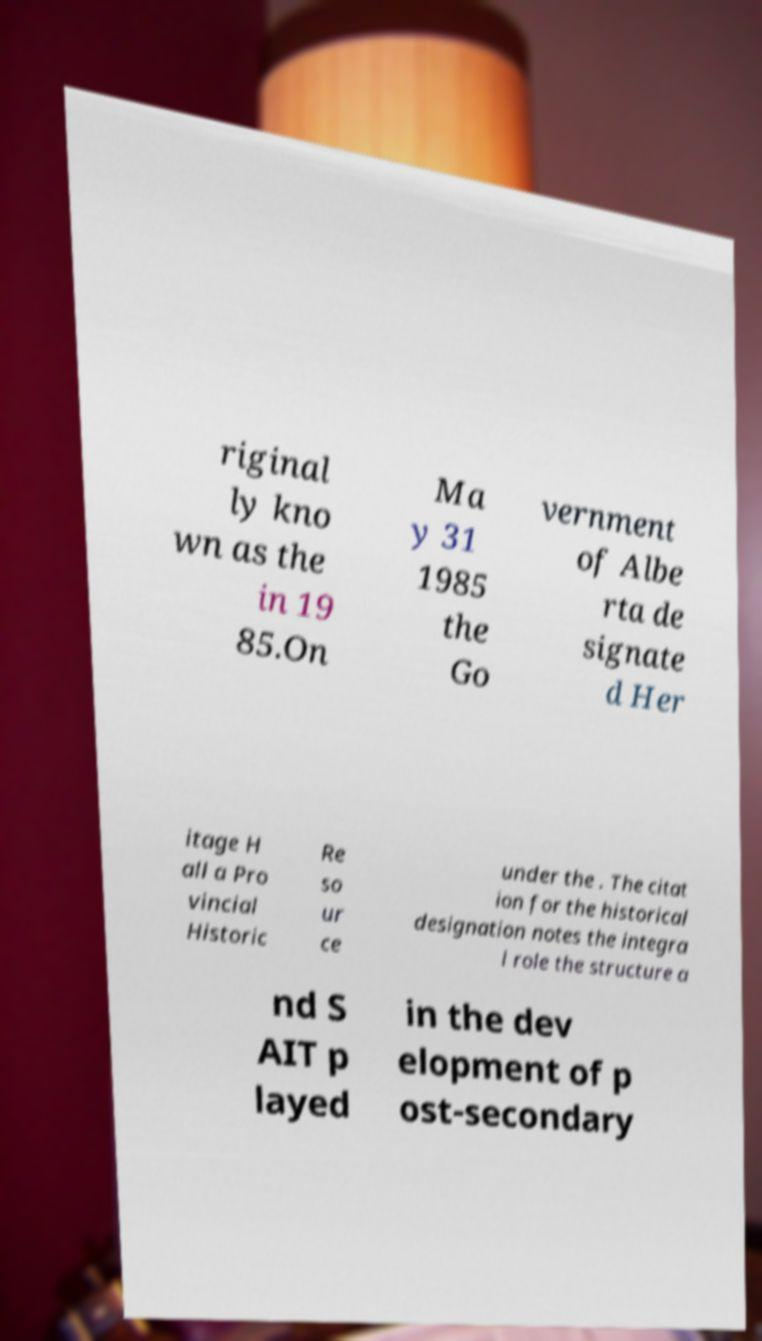Can you accurately transcribe the text from the provided image for me? riginal ly kno wn as the in 19 85.On Ma y 31 1985 the Go vernment of Albe rta de signate d Her itage H all a Pro vincial Historic Re so ur ce under the . The citat ion for the historical designation notes the integra l role the structure a nd S AIT p layed in the dev elopment of p ost-secondary 